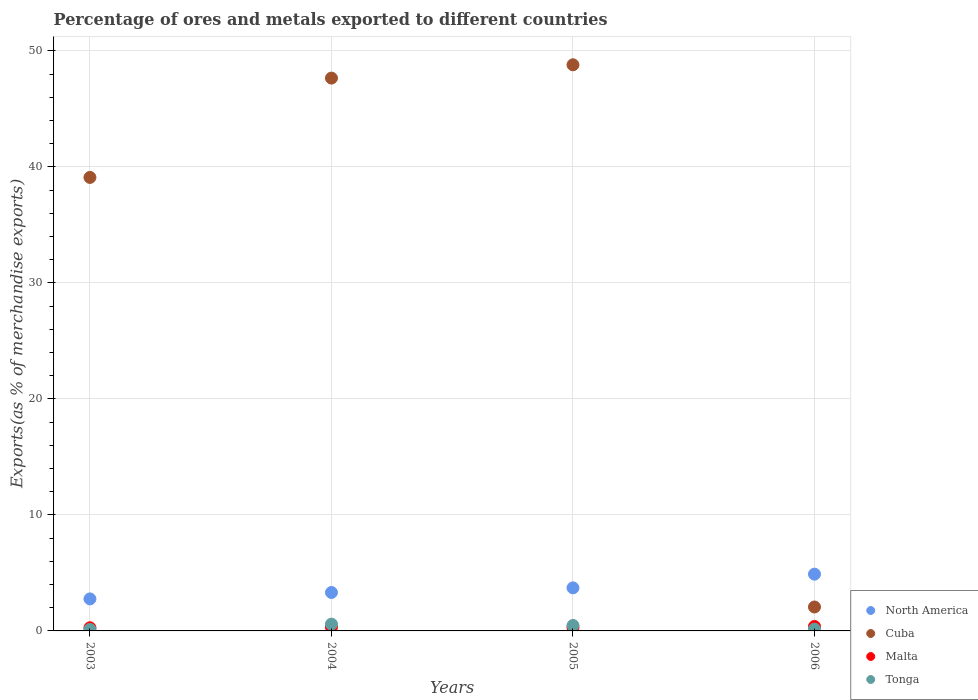What is the percentage of exports to different countries in Cuba in 2006?
Your answer should be very brief. 2.06. Across all years, what is the maximum percentage of exports to different countries in Malta?
Your response must be concise. 0.38. Across all years, what is the minimum percentage of exports to different countries in North America?
Provide a succinct answer. 2.76. What is the total percentage of exports to different countries in Tonga in the graph?
Keep it short and to the point. 1.33. What is the difference between the percentage of exports to different countries in North America in 2005 and that in 2006?
Give a very brief answer. -1.18. What is the difference between the percentage of exports to different countries in Malta in 2006 and the percentage of exports to different countries in North America in 2003?
Offer a terse response. -2.38. What is the average percentage of exports to different countries in Malta per year?
Give a very brief answer. 0.32. In the year 2004, what is the difference between the percentage of exports to different countries in Malta and percentage of exports to different countries in Tonga?
Give a very brief answer. -0.26. What is the ratio of the percentage of exports to different countries in North America in 2004 to that in 2005?
Offer a very short reply. 0.89. Is the difference between the percentage of exports to different countries in Malta in 2003 and 2005 greater than the difference between the percentage of exports to different countries in Tonga in 2003 and 2005?
Your answer should be compact. Yes. What is the difference between the highest and the second highest percentage of exports to different countries in Cuba?
Your answer should be very brief. 1.15. What is the difference between the highest and the lowest percentage of exports to different countries in Malta?
Offer a terse response. 0.11. Is the sum of the percentage of exports to different countries in North America in 2003 and 2004 greater than the maximum percentage of exports to different countries in Malta across all years?
Provide a succinct answer. Yes. Are the values on the major ticks of Y-axis written in scientific E-notation?
Offer a very short reply. No. Does the graph contain grids?
Your response must be concise. Yes. How are the legend labels stacked?
Provide a succinct answer. Vertical. What is the title of the graph?
Offer a very short reply. Percentage of ores and metals exported to different countries. Does "Burundi" appear as one of the legend labels in the graph?
Your answer should be compact. No. What is the label or title of the Y-axis?
Ensure brevity in your answer.  Exports(as % of merchandise exports). What is the Exports(as % of merchandise exports) of North America in 2003?
Keep it short and to the point. 2.76. What is the Exports(as % of merchandise exports) in Cuba in 2003?
Your answer should be compact. 39.09. What is the Exports(as % of merchandise exports) of Malta in 2003?
Give a very brief answer. 0.27. What is the Exports(as % of merchandise exports) of Tonga in 2003?
Offer a terse response. 0.12. What is the Exports(as % of merchandise exports) of North America in 2004?
Your answer should be compact. 3.31. What is the Exports(as % of merchandise exports) in Cuba in 2004?
Give a very brief answer. 47.66. What is the Exports(as % of merchandise exports) of Malta in 2004?
Your answer should be very brief. 0.33. What is the Exports(as % of merchandise exports) of Tonga in 2004?
Offer a terse response. 0.58. What is the Exports(as % of merchandise exports) in North America in 2005?
Ensure brevity in your answer.  3.71. What is the Exports(as % of merchandise exports) of Cuba in 2005?
Your response must be concise. 48.8. What is the Exports(as % of merchandise exports) of Malta in 2005?
Your answer should be very brief. 0.29. What is the Exports(as % of merchandise exports) in Tonga in 2005?
Keep it short and to the point. 0.47. What is the Exports(as % of merchandise exports) in North America in 2006?
Your answer should be very brief. 4.89. What is the Exports(as % of merchandise exports) of Cuba in 2006?
Provide a short and direct response. 2.06. What is the Exports(as % of merchandise exports) in Malta in 2006?
Make the answer very short. 0.38. What is the Exports(as % of merchandise exports) of Tonga in 2006?
Provide a succinct answer. 0.15. Across all years, what is the maximum Exports(as % of merchandise exports) in North America?
Your answer should be compact. 4.89. Across all years, what is the maximum Exports(as % of merchandise exports) in Cuba?
Provide a succinct answer. 48.8. Across all years, what is the maximum Exports(as % of merchandise exports) of Malta?
Provide a succinct answer. 0.38. Across all years, what is the maximum Exports(as % of merchandise exports) in Tonga?
Offer a terse response. 0.58. Across all years, what is the minimum Exports(as % of merchandise exports) of North America?
Offer a terse response. 2.76. Across all years, what is the minimum Exports(as % of merchandise exports) of Cuba?
Offer a terse response. 2.06. Across all years, what is the minimum Exports(as % of merchandise exports) in Malta?
Make the answer very short. 0.27. Across all years, what is the minimum Exports(as % of merchandise exports) in Tonga?
Ensure brevity in your answer.  0.12. What is the total Exports(as % of merchandise exports) of North America in the graph?
Offer a very short reply. 14.68. What is the total Exports(as % of merchandise exports) of Cuba in the graph?
Ensure brevity in your answer.  137.61. What is the total Exports(as % of merchandise exports) in Malta in the graph?
Provide a succinct answer. 1.28. What is the total Exports(as % of merchandise exports) in Tonga in the graph?
Ensure brevity in your answer.  1.33. What is the difference between the Exports(as % of merchandise exports) in North America in 2003 and that in 2004?
Provide a succinct answer. -0.55. What is the difference between the Exports(as % of merchandise exports) in Cuba in 2003 and that in 2004?
Offer a terse response. -8.56. What is the difference between the Exports(as % of merchandise exports) of Malta in 2003 and that in 2004?
Keep it short and to the point. -0.06. What is the difference between the Exports(as % of merchandise exports) in Tonga in 2003 and that in 2004?
Offer a very short reply. -0.46. What is the difference between the Exports(as % of merchandise exports) in North America in 2003 and that in 2005?
Your response must be concise. -0.95. What is the difference between the Exports(as % of merchandise exports) in Cuba in 2003 and that in 2005?
Provide a succinct answer. -9.71. What is the difference between the Exports(as % of merchandise exports) of Malta in 2003 and that in 2005?
Ensure brevity in your answer.  -0.02. What is the difference between the Exports(as % of merchandise exports) of Tonga in 2003 and that in 2005?
Offer a very short reply. -0.35. What is the difference between the Exports(as % of merchandise exports) of North America in 2003 and that in 2006?
Give a very brief answer. -2.13. What is the difference between the Exports(as % of merchandise exports) of Cuba in 2003 and that in 2006?
Provide a succinct answer. 37.03. What is the difference between the Exports(as % of merchandise exports) in Malta in 2003 and that in 2006?
Give a very brief answer. -0.11. What is the difference between the Exports(as % of merchandise exports) in Tonga in 2003 and that in 2006?
Provide a short and direct response. -0.03. What is the difference between the Exports(as % of merchandise exports) of North America in 2004 and that in 2005?
Ensure brevity in your answer.  -0.4. What is the difference between the Exports(as % of merchandise exports) of Cuba in 2004 and that in 2005?
Provide a succinct answer. -1.15. What is the difference between the Exports(as % of merchandise exports) of Malta in 2004 and that in 2005?
Your response must be concise. 0.03. What is the difference between the Exports(as % of merchandise exports) of Tonga in 2004 and that in 2005?
Provide a short and direct response. 0.12. What is the difference between the Exports(as % of merchandise exports) in North America in 2004 and that in 2006?
Provide a succinct answer. -1.58. What is the difference between the Exports(as % of merchandise exports) in Cuba in 2004 and that in 2006?
Offer a very short reply. 45.59. What is the difference between the Exports(as % of merchandise exports) in Malta in 2004 and that in 2006?
Your answer should be compact. -0.06. What is the difference between the Exports(as % of merchandise exports) of Tonga in 2004 and that in 2006?
Offer a terse response. 0.43. What is the difference between the Exports(as % of merchandise exports) of North America in 2005 and that in 2006?
Your answer should be compact. -1.18. What is the difference between the Exports(as % of merchandise exports) of Cuba in 2005 and that in 2006?
Your answer should be compact. 46.74. What is the difference between the Exports(as % of merchandise exports) in Malta in 2005 and that in 2006?
Your answer should be very brief. -0.09. What is the difference between the Exports(as % of merchandise exports) in Tonga in 2005 and that in 2006?
Offer a terse response. 0.31. What is the difference between the Exports(as % of merchandise exports) of North America in 2003 and the Exports(as % of merchandise exports) of Cuba in 2004?
Ensure brevity in your answer.  -44.9. What is the difference between the Exports(as % of merchandise exports) of North America in 2003 and the Exports(as % of merchandise exports) of Malta in 2004?
Give a very brief answer. 2.43. What is the difference between the Exports(as % of merchandise exports) in North America in 2003 and the Exports(as % of merchandise exports) in Tonga in 2004?
Make the answer very short. 2.17. What is the difference between the Exports(as % of merchandise exports) of Cuba in 2003 and the Exports(as % of merchandise exports) of Malta in 2004?
Your answer should be very brief. 38.76. What is the difference between the Exports(as % of merchandise exports) in Cuba in 2003 and the Exports(as % of merchandise exports) in Tonga in 2004?
Your answer should be compact. 38.51. What is the difference between the Exports(as % of merchandise exports) of Malta in 2003 and the Exports(as % of merchandise exports) of Tonga in 2004?
Your response must be concise. -0.31. What is the difference between the Exports(as % of merchandise exports) in North America in 2003 and the Exports(as % of merchandise exports) in Cuba in 2005?
Provide a short and direct response. -46.04. What is the difference between the Exports(as % of merchandise exports) in North America in 2003 and the Exports(as % of merchandise exports) in Malta in 2005?
Provide a short and direct response. 2.47. What is the difference between the Exports(as % of merchandise exports) of North America in 2003 and the Exports(as % of merchandise exports) of Tonga in 2005?
Ensure brevity in your answer.  2.29. What is the difference between the Exports(as % of merchandise exports) in Cuba in 2003 and the Exports(as % of merchandise exports) in Malta in 2005?
Your answer should be very brief. 38.8. What is the difference between the Exports(as % of merchandise exports) of Cuba in 2003 and the Exports(as % of merchandise exports) of Tonga in 2005?
Make the answer very short. 38.62. What is the difference between the Exports(as % of merchandise exports) in Malta in 2003 and the Exports(as % of merchandise exports) in Tonga in 2005?
Your response must be concise. -0.2. What is the difference between the Exports(as % of merchandise exports) of North America in 2003 and the Exports(as % of merchandise exports) of Cuba in 2006?
Provide a short and direct response. 0.7. What is the difference between the Exports(as % of merchandise exports) of North America in 2003 and the Exports(as % of merchandise exports) of Malta in 2006?
Offer a very short reply. 2.38. What is the difference between the Exports(as % of merchandise exports) in North America in 2003 and the Exports(as % of merchandise exports) in Tonga in 2006?
Provide a succinct answer. 2.6. What is the difference between the Exports(as % of merchandise exports) of Cuba in 2003 and the Exports(as % of merchandise exports) of Malta in 2006?
Provide a succinct answer. 38.71. What is the difference between the Exports(as % of merchandise exports) of Cuba in 2003 and the Exports(as % of merchandise exports) of Tonga in 2006?
Provide a short and direct response. 38.94. What is the difference between the Exports(as % of merchandise exports) in Malta in 2003 and the Exports(as % of merchandise exports) in Tonga in 2006?
Offer a very short reply. 0.12. What is the difference between the Exports(as % of merchandise exports) in North America in 2004 and the Exports(as % of merchandise exports) in Cuba in 2005?
Keep it short and to the point. -45.49. What is the difference between the Exports(as % of merchandise exports) of North America in 2004 and the Exports(as % of merchandise exports) of Malta in 2005?
Ensure brevity in your answer.  3.02. What is the difference between the Exports(as % of merchandise exports) in North America in 2004 and the Exports(as % of merchandise exports) in Tonga in 2005?
Provide a short and direct response. 2.84. What is the difference between the Exports(as % of merchandise exports) in Cuba in 2004 and the Exports(as % of merchandise exports) in Malta in 2005?
Give a very brief answer. 47.36. What is the difference between the Exports(as % of merchandise exports) in Cuba in 2004 and the Exports(as % of merchandise exports) in Tonga in 2005?
Your answer should be compact. 47.19. What is the difference between the Exports(as % of merchandise exports) of Malta in 2004 and the Exports(as % of merchandise exports) of Tonga in 2005?
Your answer should be very brief. -0.14. What is the difference between the Exports(as % of merchandise exports) in North America in 2004 and the Exports(as % of merchandise exports) in Cuba in 2006?
Your response must be concise. 1.25. What is the difference between the Exports(as % of merchandise exports) of North America in 2004 and the Exports(as % of merchandise exports) of Malta in 2006?
Give a very brief answer. 2.93. What is the difference between the Exports(as % of merchandise exports) of North America in 2004 and the Exports(as % of merchandise exports) of Tonga in 2006?
Provide a succinct answer. 3.16. What is the difference between the Exports(as % of merchandise exports) of Cuba in 2004 and the Exports(as % of merchandise exports) of Malta in 2006?
Provide a succinct answer. 47.27. What is the difference between the Exports(as % of merchandise exports) of Cuba in 2004 and the Exports(as % of merchandise exports) of Tonga in 2006?
Provide a short and direct response. 47.5. What is the difference between the Exports(as % of merchandise exports) of Malta in 2004 and the Exports(as % of merchandise exports) of Tonga in 2006?
Keep it short and to the point. 0.17. What is the difference between the Exports(as % of merchandise exports) in North America in 2005 and the Exports(as % of merchandise exports) in Cuba in 2006?
Your response must be concise. 1.65. What is the difference between the Exports(as % of merchandise exports) of North America in 2005 and the Exports(as % of merchandise exports) of Malta in 2006?
Your answer should be very brief. 3.33. What is the difference between the Exports(as % of merchandise exports) in North America in 2005 and the Exports(as % of merchandise exports) in Tonga in 2006?
Keep it short and to the point. 3.56. What is the difference between the Exports(as % of merchandise exports) of Cuba in 2005 and the Exports(as % of merchandise exports) of Malta in 2006?
Provide a succinct answer. 48.42. What is the difference between the Exports(as % of merchandise exports) of Cuba in 2005 and the Exports(as % of merchandise exports) of Tonga in 2006?
Ensure brevity in your answer.  48.65. What is the difference between the Exports(as % of merchandise exports) in Malta in 2005 and the Exports(as % of merchandise exports) in Tonga in 2006?
Ensure brevity in your answer.  0.14. What is the average Exports(as % of merchandise exports) in North America per year?
Ensure brevity in your answer.  3.67. What is the average Exports(as % of merchandise exports) of Cuba per year?
Make the answer very short. 34.4. What is the average Exports(as % of merchandise exports) of Malta per year?
Provide a succinct answer. 0.32. In the year 2003, what is the difference between the Exports(as % of merchandise exports) of North America and Exports(as % of merchandise exports) of Cuba?
Offer a terse response. -36.33. In the year 2003, what is the difference between the Exports(as % of merchandise exports) of North America and Exports(as % of merchandise exports) of Malta?
Make the answer very short. 2.49. In the year 2003, what is the difference between the Exports(as % of merchandise exports) in North America and Exports(as % of merchandise exports) in Tonga?
Make the answer very short. 2.64. In the year 2003, what is the difference between the Exports(as % of merchandise exports) in Cuba and Exports(as % of merchandise exports) in Malta?
Your response must be concise. 38.82. In the year 2003, what is the difference between the Exports(as % of merchandise exports) in Cuba and Exports(as % of merchandise exports) in Tonga?
Offer a terse response. 38.97. In the year 2003, what is the difference between the Exports(as % of merchandise exports) in Malta and Exports(as % of merchandise exports) in Tonga?
Your response must be concise. 0.15. In the year 2004, what is the difference between the Exports(as % of merchandise exports) in North America and Exports(as % of merchandise exports) in Cuba?
Provide a succinct answer. -44.34. In the year 2004, what is the difference between the Exports(as % of merchandise exports) of North America and Exports(as % of merchandise exports) of Malta?
Provide a short and direct response. 2.98. In the year 2004, what is the difference between the Exports(as % of merchandise exports) in North America and Exports(as % of merchandise exports) in Tonga?
Provide a short and direct response. 2.73. In the year 2004, what is the difference between the Exports(as % of merchandise exports) of Cuba and Exports(as % of merchandise exports) of Malta?
Offer a terse response. 47.33. In the year 2004, what is the difference between the Exports(as % of merchandise exports) in Cuba and Exports(as % of merchandise exports) in Tonga?
Offer a very short reply. 47.07. In the year 2004, what is the difference between the Exports(as % of merchandise exports) in Malta and Exports(as % of merchandise exports) in Tonga?
Give a very brief answer. -0.26. In the year 2005, what is the difference between the Exports(as % of merchandise exports) of North America and Exports(as % of merchandise exports) of Cuba?
Your answer should be very brief. -45.09. In the year 2005, what is the difference between the Exports(as % of merchandise exports) in North America and Exports(as % of merchandise exports) in Malta?
Keep it short and to the point. 3.42. In the year 2005, what is the difference between the Exports(as % of merchandise exports) of North America and Exports(as % of merchandise exports) of Tonga?
Your response must be concise. 3.24. In the year 2005, what is the difference between the Exports(as % of merchandise exports) in Cuba and Exports(as % of merchandise exports) in Malta?
Keep it short and to the point. 48.51. In the year 2005, what is the difference between the Exports(as % of merchandise exports) of Cuba and Exports(as % of merchandise exports) of Tonga?
Offer a very short reply. 48.33. In the year 2005, what is the difference between the Exports(as % of merchandise exports) of Malta and Exports(as % of merchandise exports) of Tonga?
Provide a short and direct response. -0.17. In the year 2006, what is the difference between the Exports(as % of merchandise exports) of North America and Exports(as % of merchandise exports) of Cuba?
Provide a short and direct response. 2.83. In the year 2006, what is the difference between the Exports(as % of merchandise exports) of North America and Exports(as % of merchandise exports) of Malta?
Ensure brevity in your answer.  4.51. In the year 2006, what is the difference between the Exports(as % of merchandise exports) of North America and Exports(as % of merchandise exports) of Tonga?
Ensure brevity in your answer.  4.74. In the year 2006, what is the difference between the Exports(as % of merchandise exports) of Cuba and Exports(as % of merchandise exports) of Malta?
Offer a very short reply. 1.68. In the year 2006, what is the difference between the Exports(as % of merchandise exports) in Cuba and Exports(as % of merchandise exports) in Tonga?
Offer a very short reply. 1.91. In the year 2006, what is the difference between the Exports(as % of merchandise exports) in Malta and Exports(as % of merchandise exports) in Tonga?
Your answer should be very brief. 0.23. What is the ratio of the Exports(as % of merchandise exports) in North America in 2003 to that in 2004?
Ensure brevity in your answer.  0.83. What is the ratio of the Exports(as % of merchandise exports) in Cuba in 2003 to that in 2004?
Provide a succinct answer. 0.82. What is the ratio of the Exports(as % of merchandise exports) in Malta in 2003 to that in 2004?
Your answer should be compact. 0.83. What is the ratio of the Exports(as % of merchandise exports) of Tonga in 2003 to that in 2004?
Make the answer very short. 0.21. What is the ratio of the Exports(as % of merchandise exports) in North America in 2003 to that in 2005?
Provide a succinct answer. 0.74. What is the ratio of the Exports(as % of merchandise exports) in Cuba in 2003 to that in 2005?
Offer a terse response. 0.8. What is the ratio of the Exports(as % of merchandise exports) in Malta in 2003 to that in 2005?
Your answer should be very brief. 0.92. What is the ratio of the Exports(as % of merchandise exports) in Tonga in 2003 to that in 2005?
Your answer should be compact. 0.26. What is the ratio of the Exports(as % of merchandise exports) in North America in 2003 to that in 2006?
Your answer should be very brief. 0.56. What is the ratio of the Exports(as % of merchandise exports) of Cuba in 2003 to that in 2006?
Make the answer very short. 18.96. What is the ratio of the Exports(as % of merchandise exports) in Malta in 2003 to that in 2006?
Give a very brief answer. 0.71. What is the ratio of the Exports(as % of merchandise exports) in Tonga in 2003 to that in 2006?
Provide a succinct answer. 0.8. What is the ratio of the Exports(as % of merchandise exports) in North America in 2004 to that in 2005?
Give a very brief answer. 0.89. What is the ratio of the Exports(as % of merchandise exports) in Cuba in 2004 to that in 2005?
Make the answer very short. 0.98. What is the ratio of the Exports(as % of merchandise exports) of Malta in 2004 to that in 2005?
Make the answer very short. 1.11. What is the ratio of the Exports(as % of merchandise exports) in Tonga in 2004 to that in 2005?
Make the answer very short. 1.25. What is the ratio of the Exports(as % of merchandise exports) in North America in 2004 to that in 2006?
Make the answer very short. 0.68. What is the ratio of the Exports(as % of merchandise exports) in Cuba in 2004 to that in 2006?
Provide a short and direct response. 23.11. What is the ratio of the Exports(as % of merchandise exports) of Malta in 2004 to that in 2006?
Ensure brevity in your answer.  0.86. What is the ratio of the Exports(as % of merchandise exports) in Tonga in 2004 to that in 2006?
Offer a terse response. 3.78. What is the ratio of the Exports(as % of merchandise exports) of North America in 2005 to that in 2006?
Ensure brevity in your answer.  0.76. What is the ratio of the Exports(as % of merchandise exports) of Cuba in 2005 to that in 2006?
Ensure brevity in your answer.  23.66. What is the ratio of the Exports(as % of merchandise exports) of Malta in 2005 to that in 2006?
Offer a very short reply. 0.77. What is the ratio of the Exports(as % of merchandise exports) in Tonga in 2005 to that in 2006?
Provide a short and direct response. 3.03. What is the difference between the highest and the second highest Exports(as % of merchandise exports) of North America?
Offer a terse response. 1.18. What is the difference between the highest and the second highest Exports(as % of merchandise exports) of Cuba?
Your answer should be very brief. 1.15. What is the difference between the highest and the second highest Exports(as % of merchandise exports) in Malta?
Make the answer very short. 0.06. What is the difference between the highest and the second highest Exports(as % of merchandise exports) in Tonga?
Ensure brevity in your answer.  0.12. What is the difference between the highest and the lowest Exports(as % of merchandise exports) of North America?
Offer a very short reply. 2.13. What is the difference between the highest and the lowest Exports(as % of merchandise exports) of Cuba?
Offer a terse response. 46.74. What is the difference between the highest and the lowest Exports(as % of merchandise exports) of Malta?
Keep it short and to the point. 0.11. What is the difference between the highest and the lowest Exports(as % of merchandise exports) of Tonga?
Make the answer very short. 0.46. 